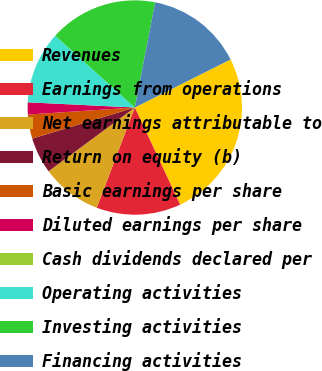Convert chart to OTSL. <chart><loc_0><loc_0><loc_500><loc_500><pie_chart><fcel>Revenues<fcel>Earnings from operations<fcel>Net earnings attributable to<fcel>Return on equity (b)<fcel>Basic earnings per share<fcel>Diluted earnings per share<fcel>Cash dividends declared per<fcel>Operating activities<fcel>Investing activities<fcel>Financing activities<nl><fcel>25.45%<fcel>12.73%<fcel>9.09%<fcel>5.45%<fcel>3.64%<fcel>1.82%<fcel>0.0%<fcel>10.91%<fcel>16.36%<fcel>14.55%<nl></chart> 